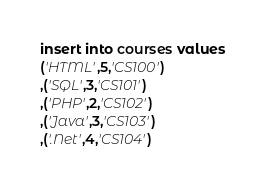Convert code to text. <code><loc_0><loc_0><loc_500><loc_500><_SQL_>insert into courses values
('HTML',5,'CS100')
,('SQL',3,'CS101')
,('PHP',2,'CS102')
,('Java',3,'CS103')
,('.Net',4,'CS104')
</code> 